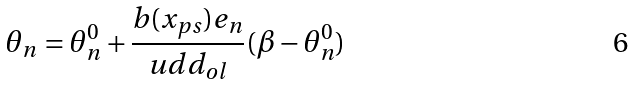Convert formula to latex. <formula><loc_0><loc_0><loc_500><loc_500>\theta _ { n } = \theta _ { n } ^ { 0 } + \frac { b ( x _ { p s } ) e _ { n } } { u d d _ { o l } } ( \beta - \theta _ { n } ^ { 0 } )</formula> 